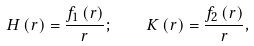<formula> <loc_0><loc_0><loc_500><loc_500>H \left ( r \right ) = \frac { f _ { 1 } \left ( r \right ) } { r } ; \quad K \left ( r \right ) = \frac { f _ { 2 } \left ( r \right ) } { r } ,</formula> 